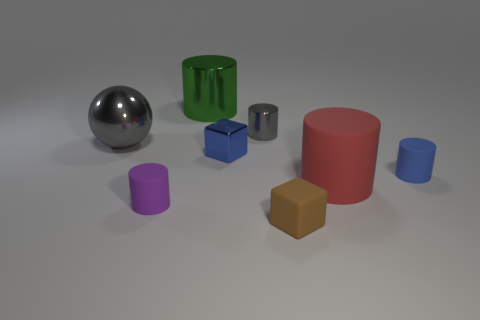Are there any gray things on the right side of the blue shiny object?
Your answer should be compact. Yes. Are there more small blue shiny things that are in front of the big gray object than small rubber cylinders that are left of the tiny purple cylinder?
Ensure brevity in your answer.  Yes. There is a blue object that is the same shape as the green metallic thing; what size is it?
Ensure brevity in your answer.  Small. How many blocks are either tiny brown things or tiny matte things?
Provide a succinct answer. 1. There is a tiny cylinder that is the same color as the large metallic ball; what material is it?
Provide a short and direct response. Metal. Are there fewer large shiny cylinders in front of the small brown rubber block than tiny cylinders that are to the right of the big green metallic object?
Offer a terse response. Yes. What number of things are either small things left of the small rubber cube or red objects?
Your answer should be very brief. 4. The big object behind the gray metal object that is left of the gray metal cylinder is what shape?
Your response must be concise. Cylinder. Is there a blue shiny block that has the same size as the metallic sphere?
Provide a short and direct response. No. Are there more blue metal cubes than small shiny things?
Offer a very short reply. No. 